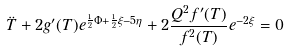Convert formula to latex. <formula><loc_0><loc_0><loc_500><loc_500>\ddot { T } + 2 g ^ { \prime } ( T ) e ^ { \frac { 1 } { 2 } \Phi + \frac { 1 } { 2 } \xi - 5 \eta } + 2 \frac { Q ^ { 2 } f ^ { \prime } ( T ) } { f ^ { 2 } ( T ) } e ^ { - 2 \xi } = 0</formula> 